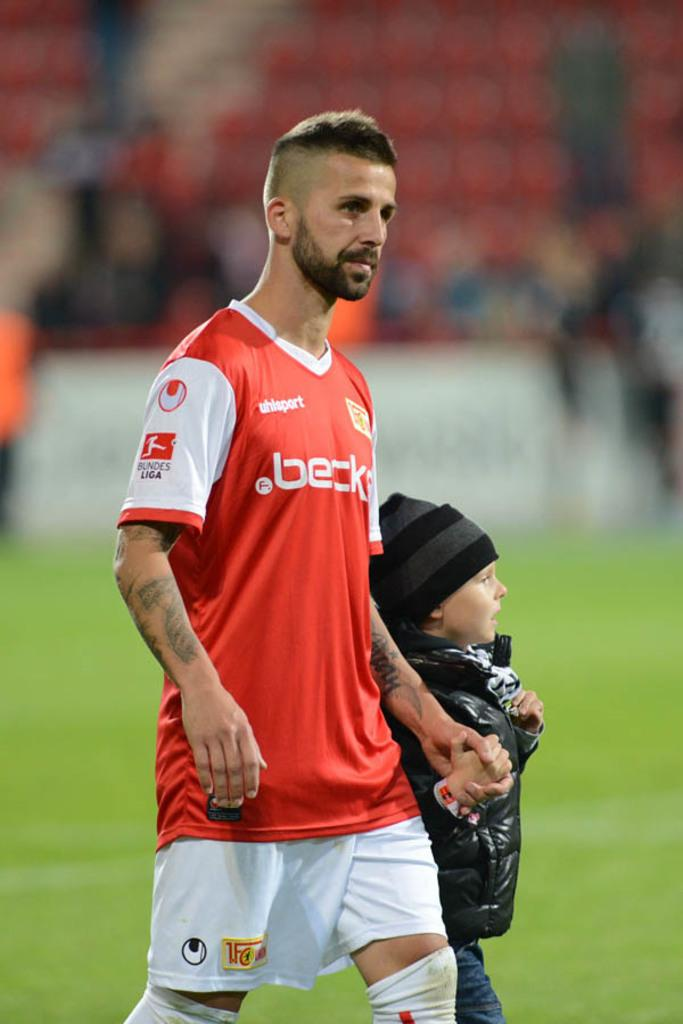Who can be seen in the foreground of the image? There is a man and a child in the foreground of the image. What can be observed about the background of the image? The background of the image is blurry. How many chickens are present in the image? There are no chickens present in the image. What belief system is represented by the people in the image? The provided facts do not mention any belief system, so it cannot be determined from the image. 